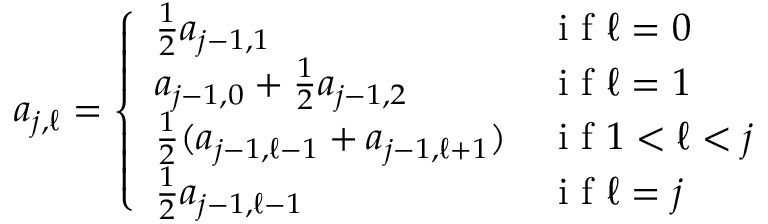Convert formula to latex. <formula><loc_0><loc_0><loc_500><loc_500>\begin{array} { r } { a _ { j , \ell } = \left \{ \begin{array} { l l } { \frac { 1 } { 2 } a _ { j - 1 , 1 } } & { i f \ell = 0 } \\ { a _ { j - 1 , 0 } + \frac { 1 } { 2 } a _ { j - 1 , 2 } } & { i f \ell = 1 } \\ { \frac { 1 } { 2 } ( a _ { j - 1 , \ell - 1 } + a _ { j - 1 , \ell + 1 } ) } & { i f 1 < \ell < j } \\ { \frac { 1 } { 2 } a _ { j - 1 , \ell - 1 } } & { i f \ell = j } \end{array} } \end{array}</formula> 